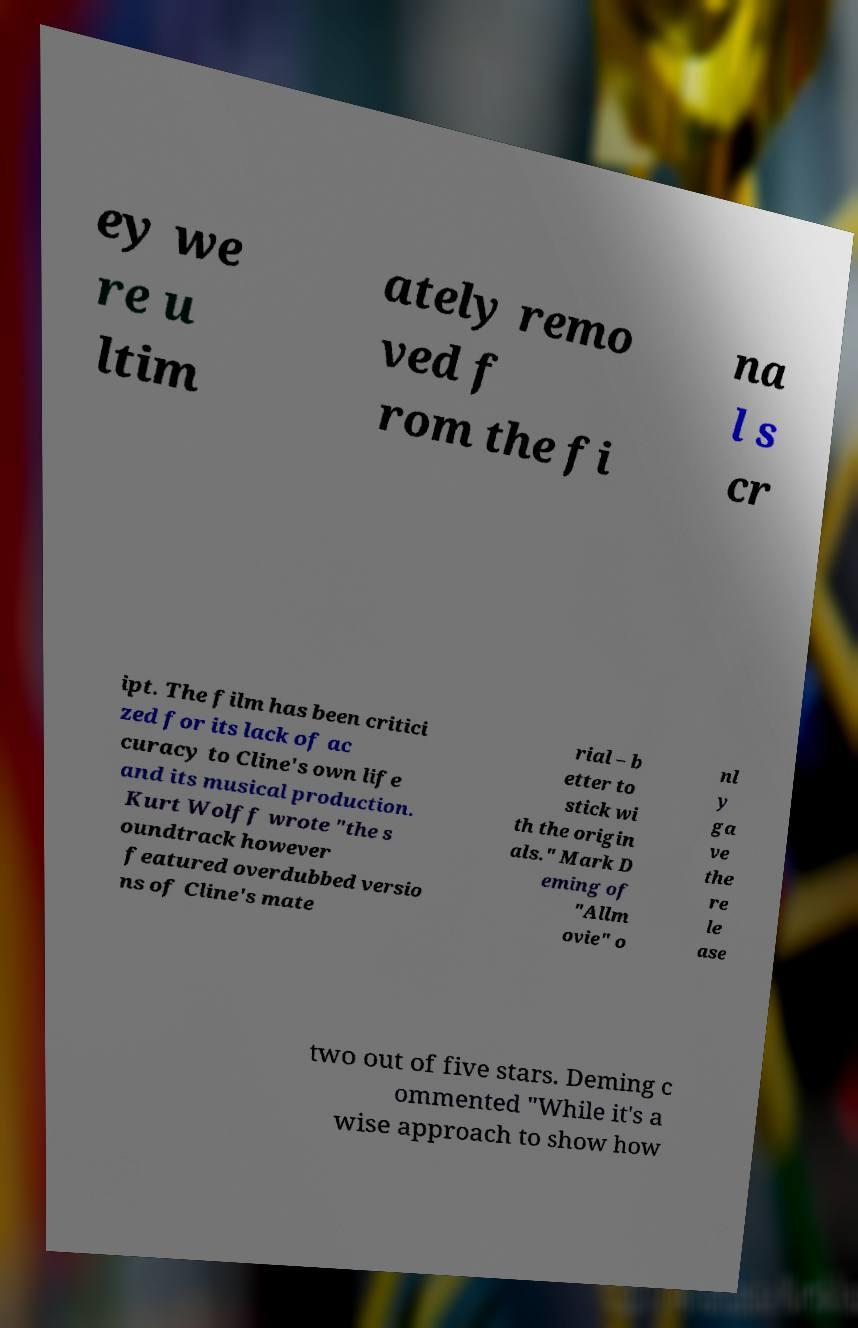Please read and relay the text visible in this image. What does it say? ey we re u ltim ately remo ved f rom the fi na l s cr ipt. The film has been critici zed for its lack of ac curacy to Cline's own life and its musical production. Kurt Wolff wrote "the s oundtrack however featured overdubbed versio ns of Cline's mate rial – b etter to stick wi th the origin als." Mark D eming of "Allm ovie" o nl y ga ve the re le ase two out of five stars. Deming c ommented "While it's a wise approach to show how 